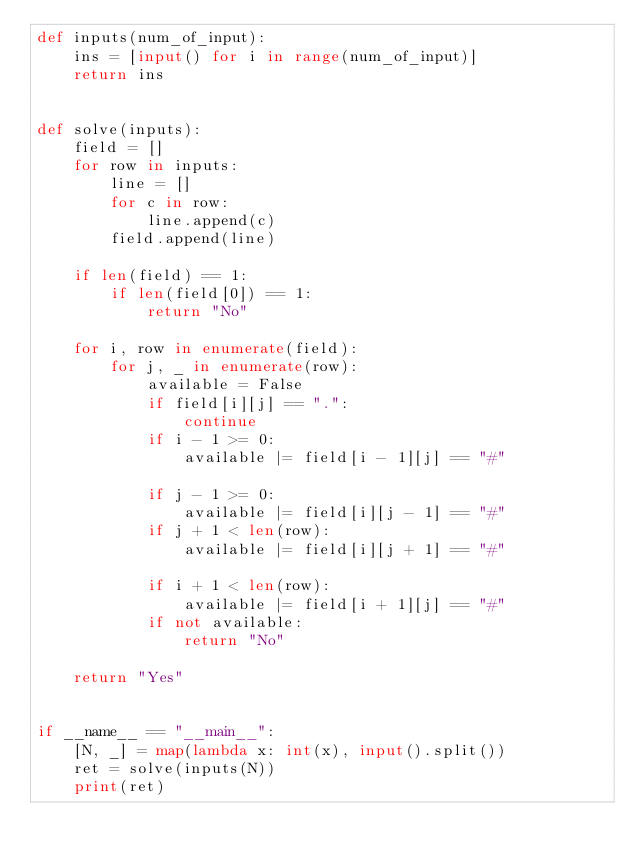<code> <loc_0><loc_0><loc_500><loc_500><_Python_>def inputs(num_of_input):
    ins = [input() for i in range(num_of_input)]
    return ins


def solve(inputs):
    field = []
    for row in inputs:
        line = []
        for c in row:
            line.append(c)
        field.append(line)

    if len(field) == 1:
        if len(field[0]) == 1:
            return "No"

    for i, row in enumerate(field):
        for j, _ in enumerate(row):
            available = False
            if field[i][j] == ".":
                continue
            if i - 1 >= 0:
                available |= field[i - 1][j] == "#"

            if j - 1 >= 0:
                available |= field[i][j - 1] == "#"
            if j + 1 < len(row):
                available |= field[i][j + 1] == "#"

            if i + 1 < len(row):
                available |= field[i + 1][j] == "#"
            if not available:
                return "No"

    return "Yes"


if __name__ == "__main__":
    [N, _] = map(lambda x: int(x), input().split())
    ret = solve(inputs(N))
    print(ret)
</code> 